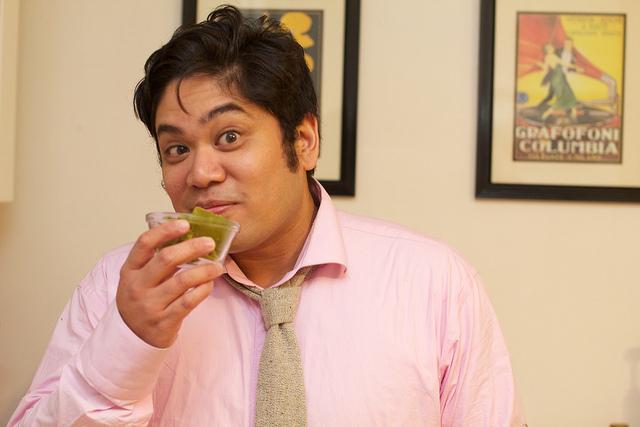What does the man have around his neck?
Write a very short answer. Tie. What food is he eating?
Concise answer only. Sandwich. What color is the tie?
Quick response, please. Tan. Are they drinking margaritas?
Short answer required. No. Is this a woman?
Write a very short answer. No. Is the man biting a piece of pizza?
Short answer required. No. Is this person wearing glasses?
Write a very short answer. No. What color is his shirt?
Give a very brief answer. Pink. What is he drinking?
Quick response, please. Cocktail. What is the man holding?
Write a very short answer. Glass. 